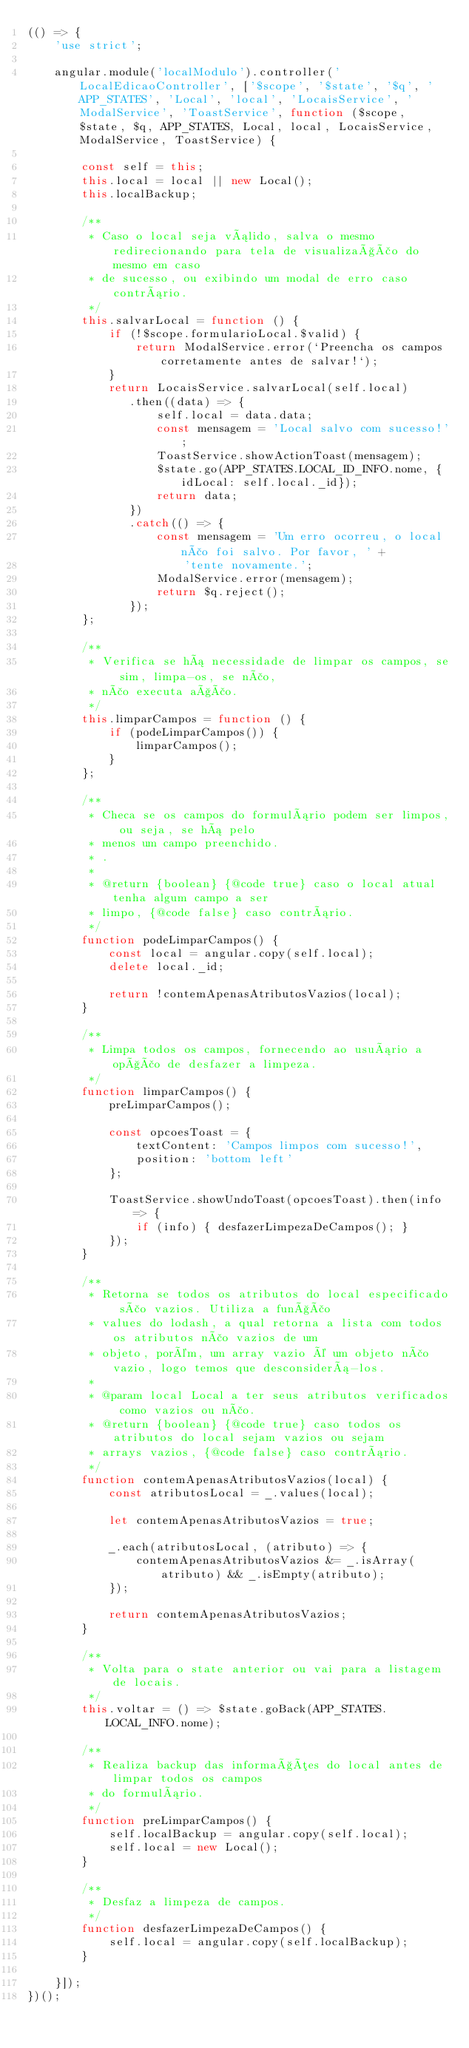<code> <loc_0><loc_0><loc_500><loc_500><_JavaScript_>(() => {
    'use strict';

    angular.module('localModulo').controller('LocalEdicaoController', ['$scope', '$state', '$q', 'APP_STATES', 'Local', 'local', 'LocaisService', 'ModalService', 'ToastService', function ($scope, $state, $q, APP_STATES, Local, local, LocaisService, ModalService, ToastService) {

        const self = this;
        this.local = local || new Local();
        this.localBackup;

        /**
         * Caso o local seja válido, salva o mesmo redirecionando para tela de visualização do mesmo em caso
         * de sucesso, ou exibindo um modal de erro caso contrário.
         */
        this.salvarLocal = function () {
            if (!$scope.formularioLocal.$valid) {
                return ModalService.error(`Preencha os campos corretamente antes de salvar!`);
            }
            return LocaisService.salvarLocal(self.local)
               .then((data) => {
                   self.local = data.data;
                   const mensagem = 'Local salvo com sucesso!';
                   ToastService.showActionToast(mensagem);
                   $state.go(APP_STATES.LOCAL_ID_INFO.nome, {idLocal: self.local._id});
                   return data;
               })
               .catch(() => {
                   const mensagem = 'Um erro ocorreu, o local não foi salvo. Por favor, ' +
                       'tente novamente.';
                   ModalService.error(mensagem);
                   return $q.reject();
               });
        };

        /**
         * Verifica se há necessidade de limpar os campos, se sim, limpa-os, se não,
         * não executa ação.
         */
        this.limparCampos = function () {
            if (podeLimparCampos()) {
                limparCampos();
            }
        };

        /**
         * Checa se os campos do formulário podem ser limpos, ou seja, se há pelo
         * menos um campo preenchido.
         * .
         *
         * @return {boolean} {@code true} caso o local atual tenha algum campo a ser
         * limpo, {@code false} caso contrário.
         */
        function podeLimparCampos() {
            const local = angular.copy(self.local);
            delete local._id;

            return !contemApenasAtributosVazios(local);
        }

        /**
         * Limpa todos os campos, fornecendo ao usuário a opção de desfazer a limpeza.
         */
        function limparCampos() {
            preLimparCampos();

            const opcoesToast = {
                textContent: 'Campos limpos com sucesso!',
                position: 'bottom left'
            };

            ToastService.showUndoToast(opcoesToast).then(info => {
                if (info) { desfazerLimpezaDeCampos(); }
            });
        }

        /**
         * Retorna se todos os atributos do local especificado são vazios. Utiliza a função
         * values do lodash, a qual retorna a lista com todos os atributos não vazios de um
         * objeto, porém, um array vazio é um objeto não vazio, logo temos que desconsiderá-los.
         *
         * @param local Local a ter seus atributos verificados como vazios ou não.
         * @return {boolean} {@code true} caso todos os atributos do local sejam vazios ou sejam
         * arrays vazios, {@code false} caso contrário.
         */
        function contemApenasAtributosVazios(local) {
            const atributosLocal = _.values(local);

            let contemApenasAtributosVazios = true;

            _.each(atributosLocal, (atributo) => {
                contemApenasAtributosVazios &= _.isArray(atributo) && _.isEmpty(atributo);
            });

            return contemApenasAtributosVazios;
        }

        /**
         * Volta para o state anterior ou vai para a listagem de locais.
         */
        this.voltar = () => $state.goBack(APP_STATES.LOCAL_INFO.nome);

        /**
         * Realiza backup das informações do local antes de limpar todos os campos
         * do formulário.
         */
        function preLimparCampos() {
            self.localBackup = angular.copy(self.local);
            self.local = new Local();
        }

        /**
         * Desfaz a limpeza de campos.
         */
        function desfazerLimpezaDeCampos() {
            self.local = angular.copy(self.localBackup);
        }

    }]);
})();
</code> 